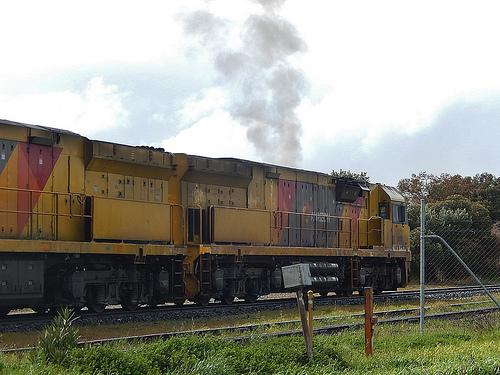Question: when was this photo taken?
Choices:
A. During the day.
B. Morning.
C. Noon.
D. Early evening.
Answer with the letter. Answer: A Question: how many people are in the photo?
Choices:
A. None.
B. Two.
C. One.
D. Four.
Answer with the letter. Answer: A Question: who is the subject of the photo?
Choices:
A. The man.
B. The children.
C. The bus.
D. The train.
Answer with the letter. Answer: D Question: why is the photo illuminated?
Choices:
A. Flashlight.
B. Sunlight.
C. Fire.
D. Indoor lighting.
Answer with the letter. Answer: B Question: what color is the sky?
Choices:
A. Blue.
B. Black.
C. Gray.
D. Pink.
Answer with the letter. Answer: C 